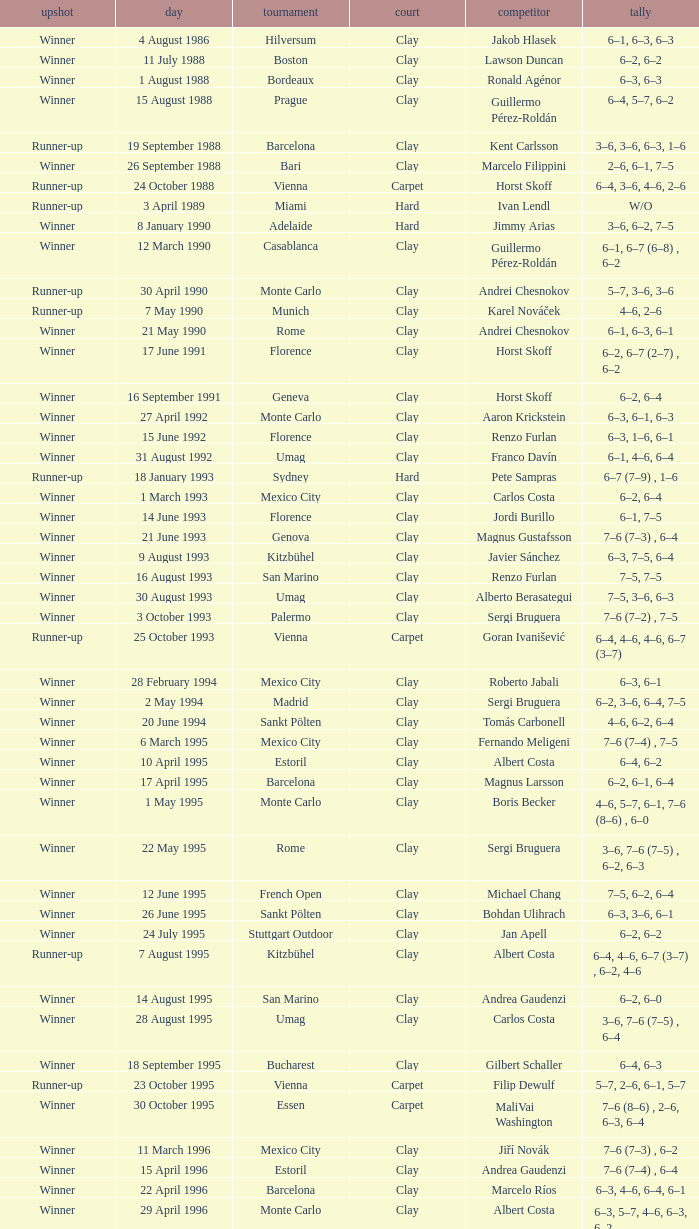Who is the opponent on 18 january 1993? Pete Sampras. 